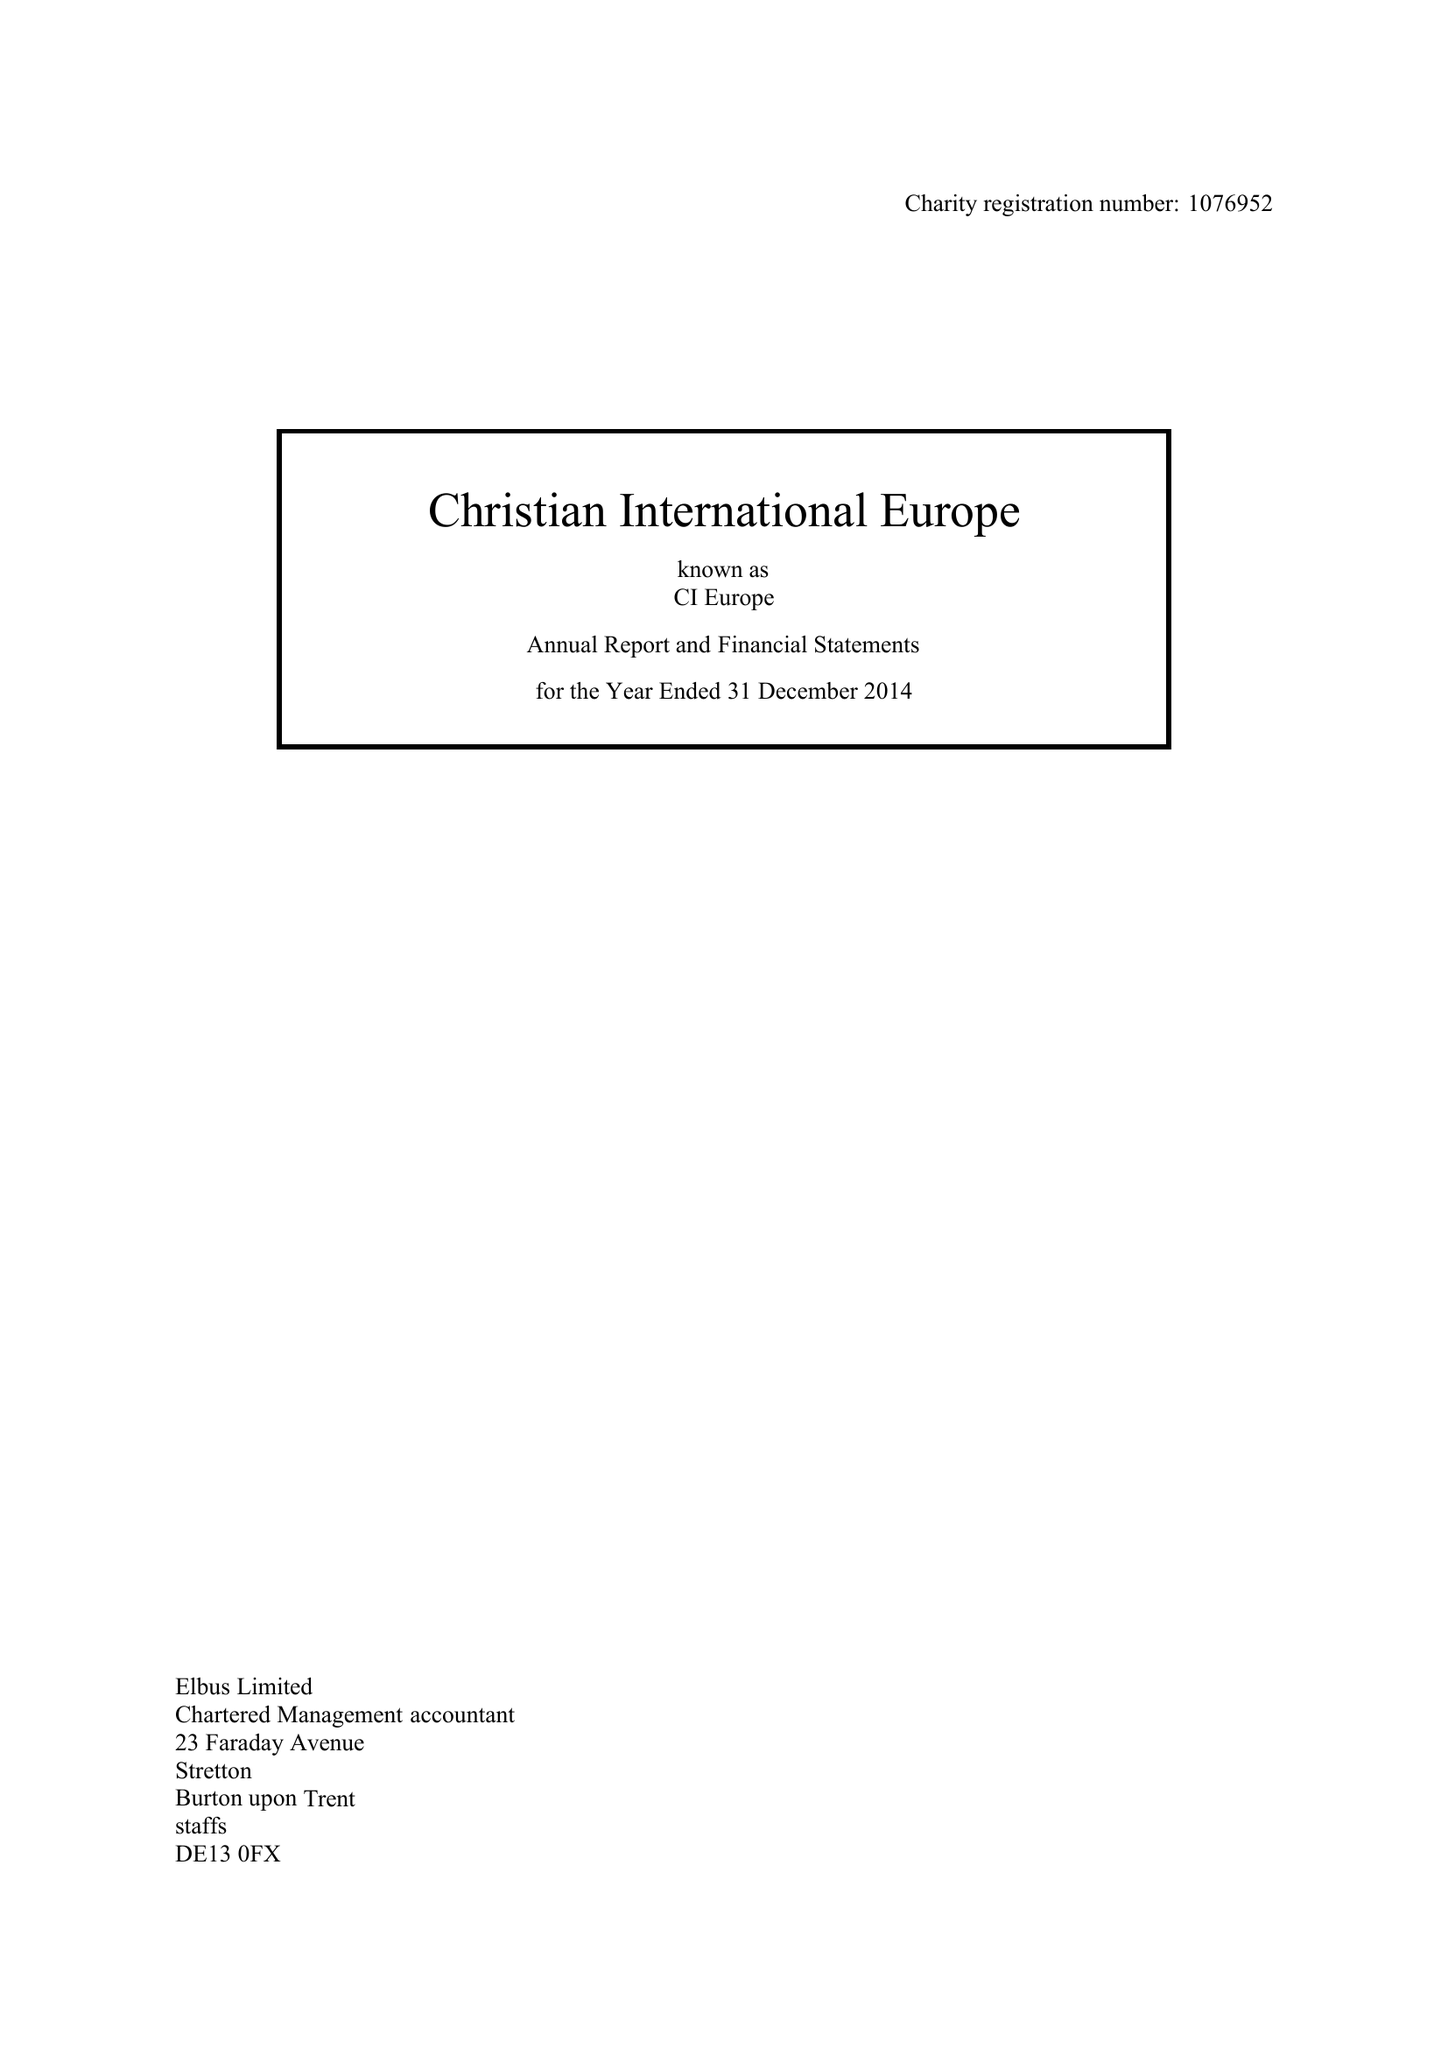What is the value for the charity_number?
Answer the question using a single word or phrase. 1076952 